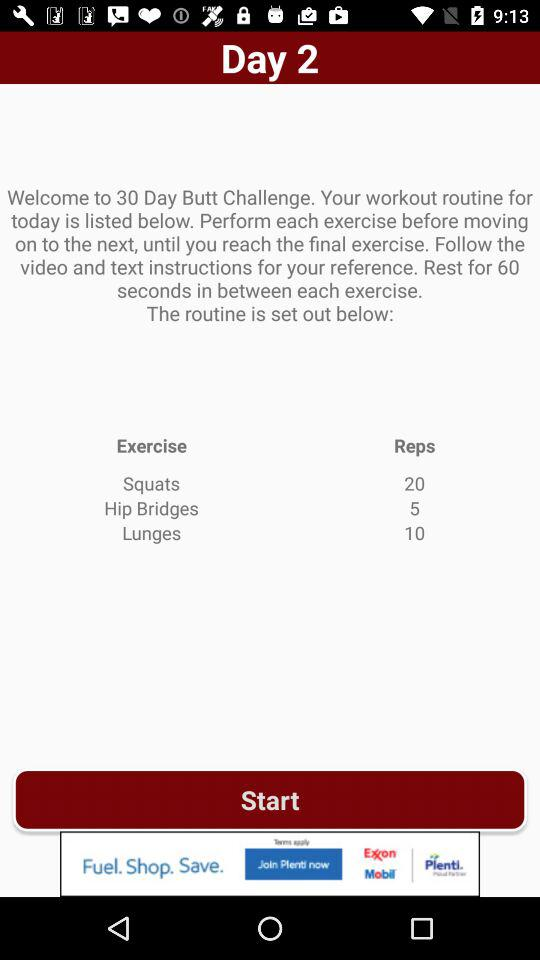How many exercises are there in total?
Answer the question using a single word or phrase. 3 